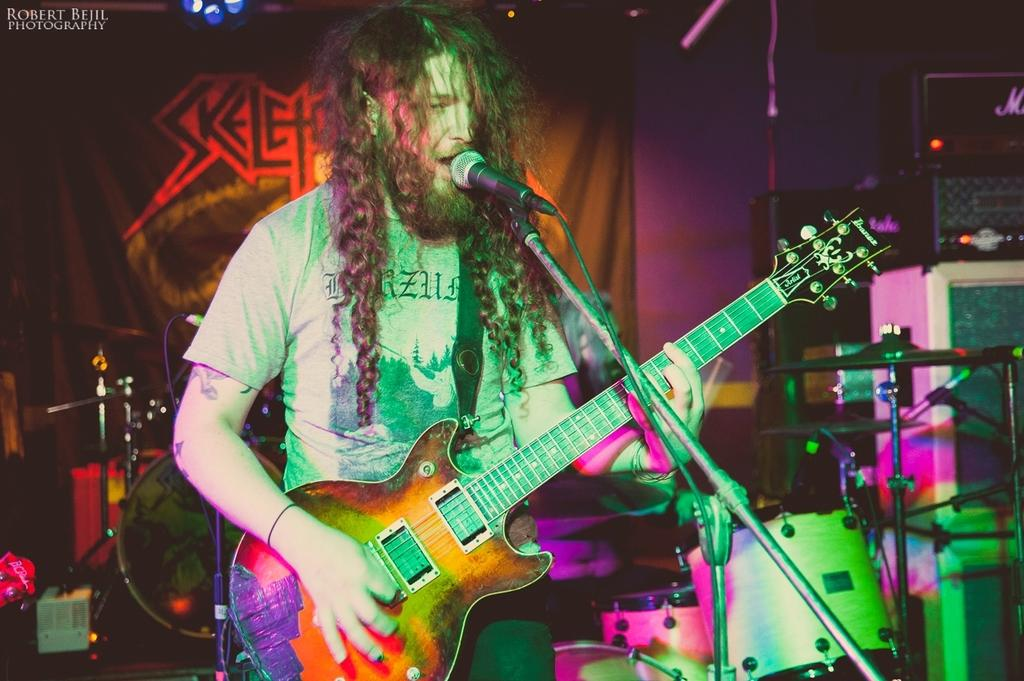Who is the main subject in the image? There is a man in the image. What is the man wearing? The man is wearing a grey t-shirt. What is the man doing in the image? The man is standing and playing a guitar. What object is in front of the man? There is a microphone in front of the man. What can be seen in the background of the image? There are musical instruments in the background of the image. What is visible at the top of the image? There is a poster visible at the top of the image. What type of spade is the man using to dig a hole in the image? There is no spade present in the image; the man is playing a guitar and there is no indication of him digging a hole. What kind of apparatus is the man using to communicate with the audience in the image? The man is using a microphone to communicate with the audience, not an apparatus. 